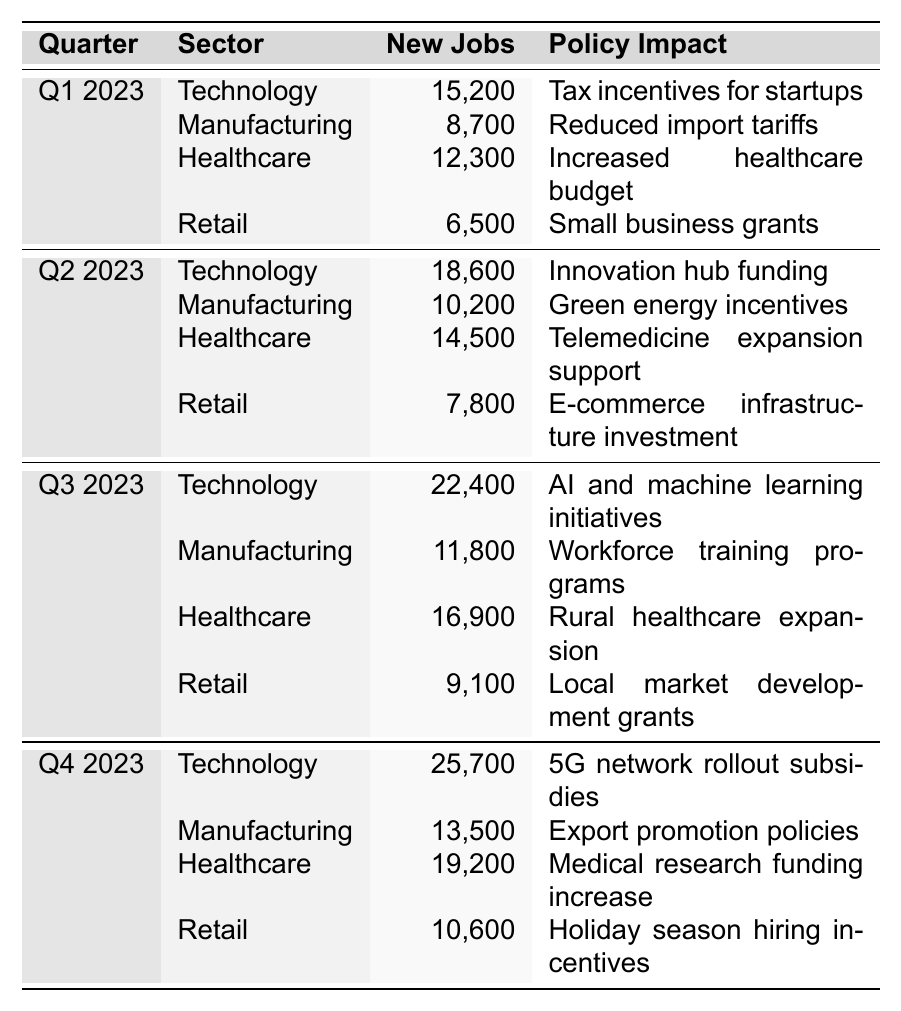What sector created the most new jobs in Q3 2023? In Q3 2023, the Technology sector created 22,400 new jobs, which is more than any other sector listed.
Answer: Technology How many new jobs were created in the Retail sector in Q2 2023? In Q2 2023, the Retail sector created 7,800 new jobs specifically.
Answer: 7,800 What was the total number of new jobs created in the Healthcare sector across all four quarters? We sum the new jobs created in the Healthcare sector: 12,300 (Q1) + 14,500 (Q2) + 16,900 (Q3) + 19,200 (Q4) = 62,900.
Answer: 62,900 Did the Manufacturing sector see an increase in job creation from Q1 to Q4 2023? Yes, the Manufacturing sector showed an increase in job creation from 8,700 in Q1 to 13,500 in Q4.
Answer: Yes What is the difference in job creation between the Technology and Healthcare sectors in Q4 2023? In Q4 2023, Technology created 25,700 jobs and Healthcare created 19,200 jobs. The difference is 25,700 - 19,200 = 6,500.
Answer: 6,500 Which quarter had the highest total new jobs created across all sectors? We calculate the total new jobs for each quarter: Q1 (15,200 + 8,700 + 12,300 + 6,500 = 42,700), Q2 (18,600 + 10,200 + 14,500 + 7,800 = 61,100), Q3 (22,400 + 11,800 + 16,900 + 9,100 = 70,200), Q4 (25,700 + 13,500 + 19,200 + 10,600 = 69,000). Q3 had the highest total at 70,200.
Answer: Q3 2023 Which sector benefitted from the "Green energy incentives" policy and how many new jobs were created? The Manufacturing sector benefitted from "Green energy incentives" and created 10,200 new jobs in Q2 2023.
Answer: 10,200 What was the average number of new jobs created in the Retail sector across all quarters? To find the average for the Retail sector, we sum the new jobs: 6,500 (Q1) + 7,800 (Q2) + 9,100 (Q3) + 10,600 (Q4) = 34,000. There are 4 quarters, so the average is 34,000 / 4 = 8,500.
Answer: 8,500 In which quarter did the Technology sector see the largest increase in job creation compared to the previous quarter? From Q1 to Q2, Technology increased by 3,400 new jobs (from 15,200 to 18,600). From Q2 to Q3, it increased by 5,800 (from 18,600 to 22,400). From Q3 to Q4, it increased by 3,300 (from 22,400 to 25,700). The largest increase was from Q2 to Q3 at 5,800 jobs.
Answer: Q2 to Q3 Was there a quarter where all sectors combined created more than 60,000 jobs? Yes, in Q2 2023 the total was 61,100 (18,600 + 10,200 + 14,500 + 7,800).
Answer: Yes 